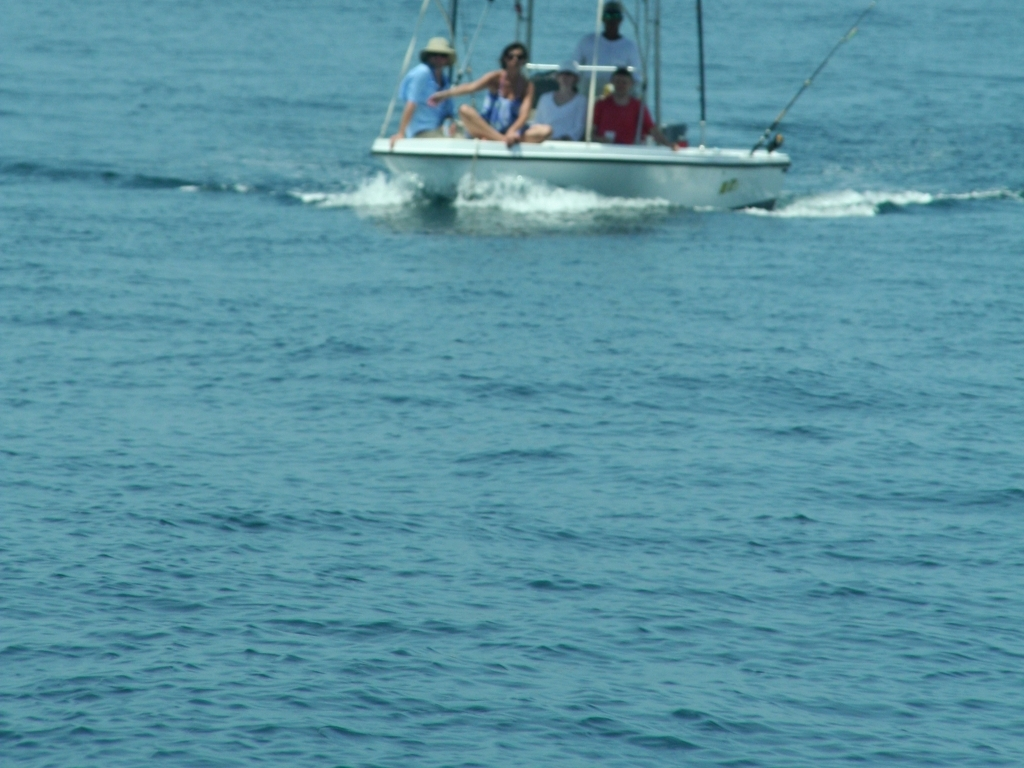What is the quality of this image?
A. Excellent
B. Average
C. Very poor
D. Good The quality of this image would be rated as 'C. Very poor' due to its noticeable blurriness and lack of sharpness, making the details unclear. It appears to be taken with a slow shutter speed or poor focus, resulting in an image that lacks the crispness and clarity expected of a high-quality photograph. The composition is centered, but the motion blur diminishes the overall aesthetic appeal. 